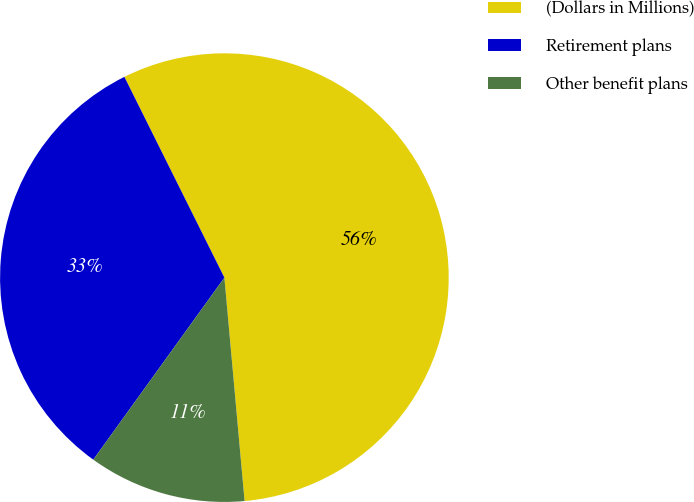Convert chart to OTSL. <chart><loc_0><loc_0><loc_500><loc_500><pie_chart><fcel>(Dollars in Millions)<fcel>Retirement plans<fcel>Other benefit plans<nl><fcel>55.92%<fcel>32.71%<fcel>11.37%<nl></chart> 